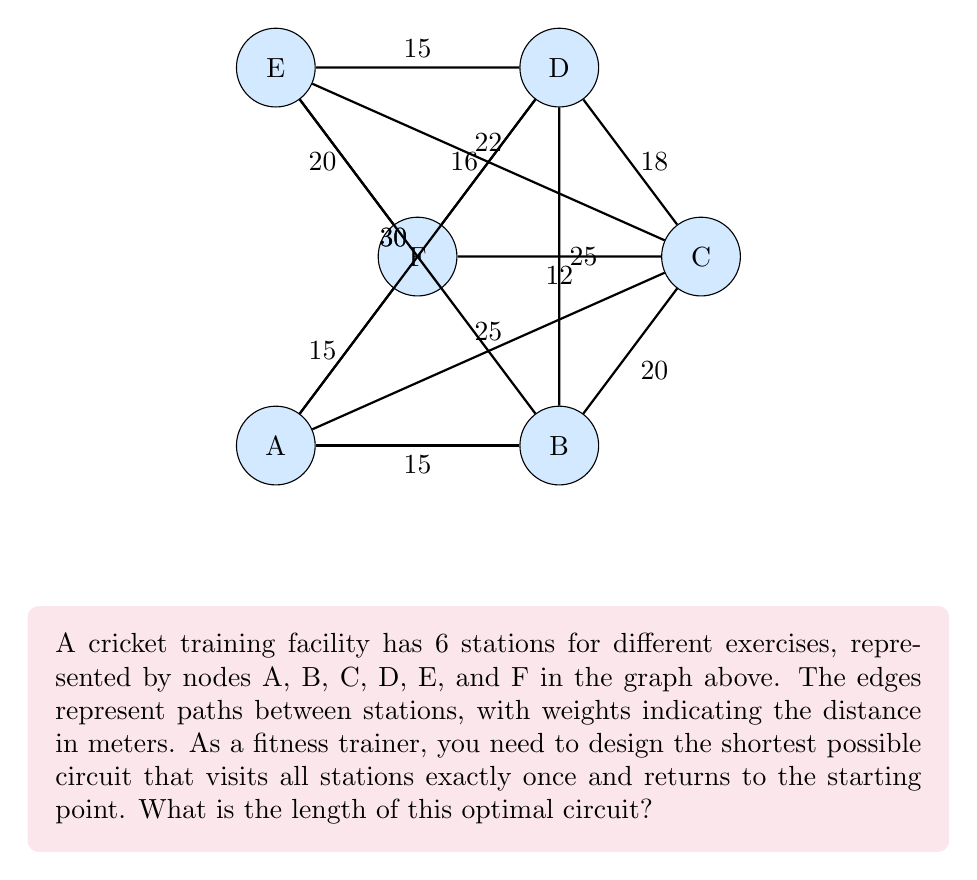What is the answer to this math problem? To solve this problem, we need to find the shortest Hamiltonian cycle in the given graph. This is known as the Traveling Salesman Problem (TSP), which is NP-hard. For a small graph like this, we can use a brute-force approach to find the optimal solution.

Steps:
1) List all possible Hamiltonian cycles:
   There are $(6-1)! = 5! = 120$ possible cycles.

2) Calculate the length of each cycle:
   For example, A-B-C-D-E-F-A has length 15 + 20 + 18 + 15 + 20 + 15 = 103m

3) Compare all cycle lengths and find the minimum:
   After checking all cycles, we find that the shortest cycle is:
   A-B-C-F-D-E-A with length 15 + 20 + 12 + 16 + 15 + 20 = 98m

Verification:
- A to B: 15m
- B to C: 20m
- C to F: 12m
- F to D: 16m
- D to E: 15m
- E to A: 20m

Total: 15 + 20 + 12 + 16 + 15 + 20 = 98m

This circuit ensures that all stations are visited once and the trainer returns to the starting point, covering the minimum possible distance.
Answer: 98 meters 